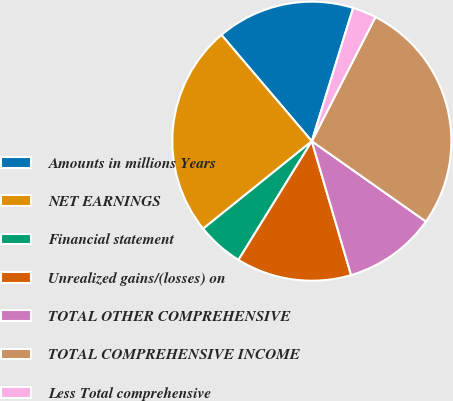Convert chart to OTSL. <chart><loc_0><loc_0><loc_500><loc_500><pie_chart><fcel>Amounts in millions Years<fcel>NET EARNINGS<fcel>Financial statement<fcel>Unrealized gains/(losses) on<fcel>TOTAL OTHER COMPREHENSIVE<fcel>TOTAL COMPREHENSIVE INCOME<fcel>Less Total comprehensive<nl><fcel>16.0%<fcel>24.58%<fcel>5.4%<fcel>13.35%<fcel>10.7%<fcel>27.23%<fcel>2.75%<nl></chart> 